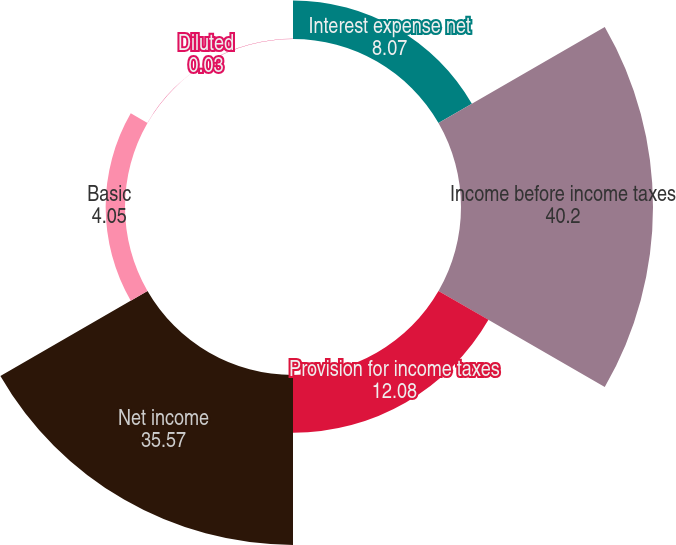<chart> <loc_0><loc_0><loc_500><loc_500><pie_chart><fcel>Interest expense net<fcel>Income before income taxes<fcel>Provision for income taxes<fcel>Net income<fcel>Basic<fcel>Diluted<nl><fcel>8.07%<fcel>40.2%<fcel>12.08%<fcel>35.57%<fcel>4.05%<fcel>0.03%<nl></chart> 